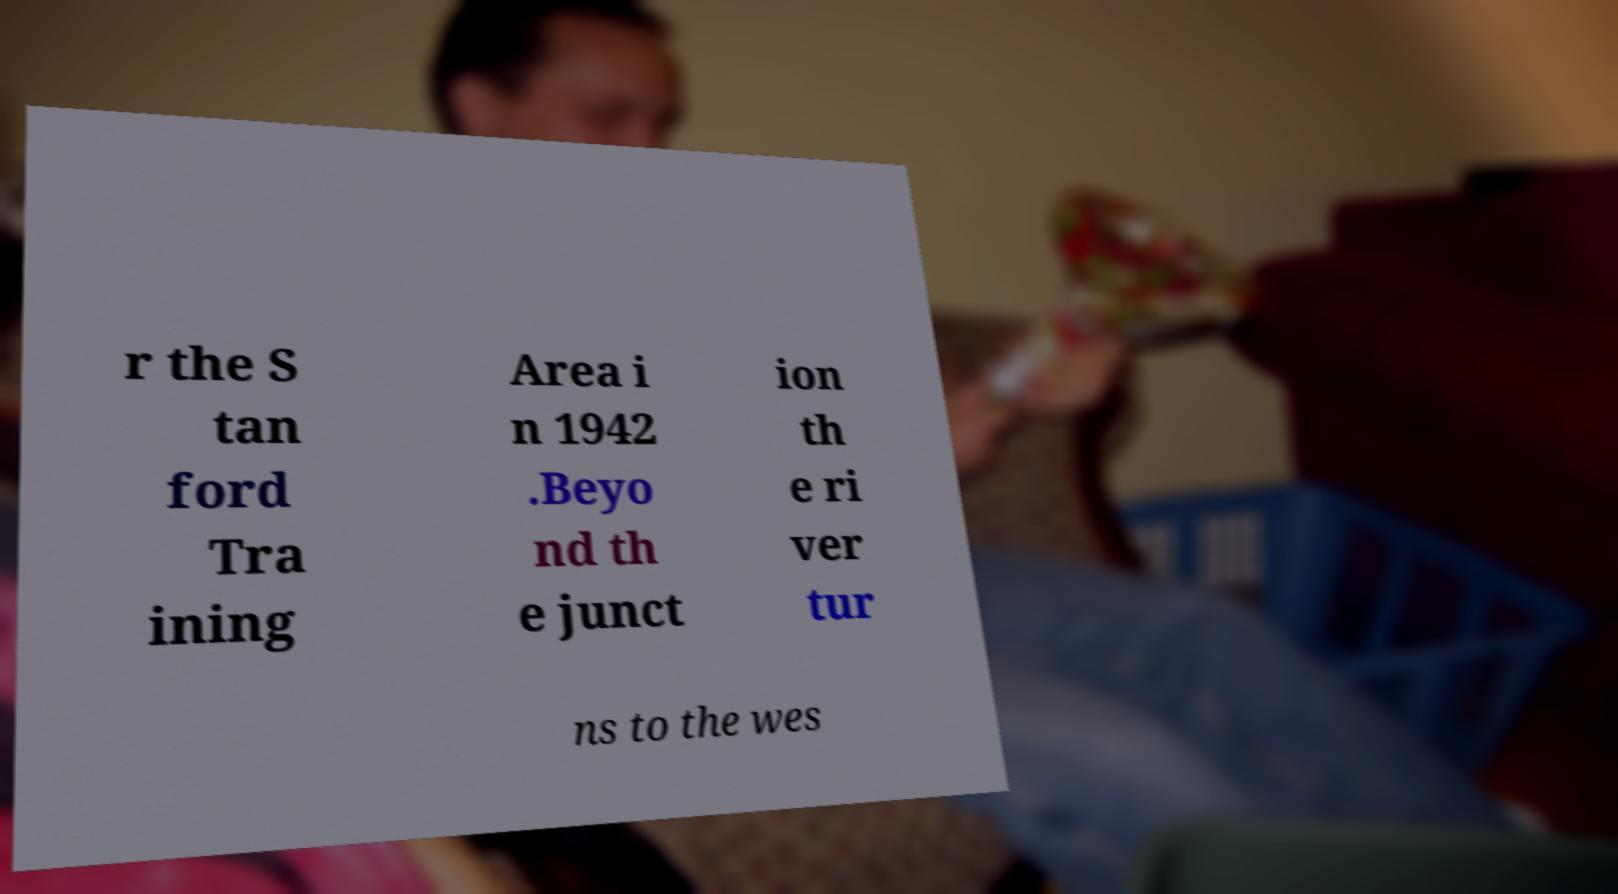There's text embedded in this image that I need extracted. Can you transcribe it verbatim? r the S tan ford Tra ining Area i n 1942 .Beyo nd th e junct ion th e ri ver tur ns to the wes 